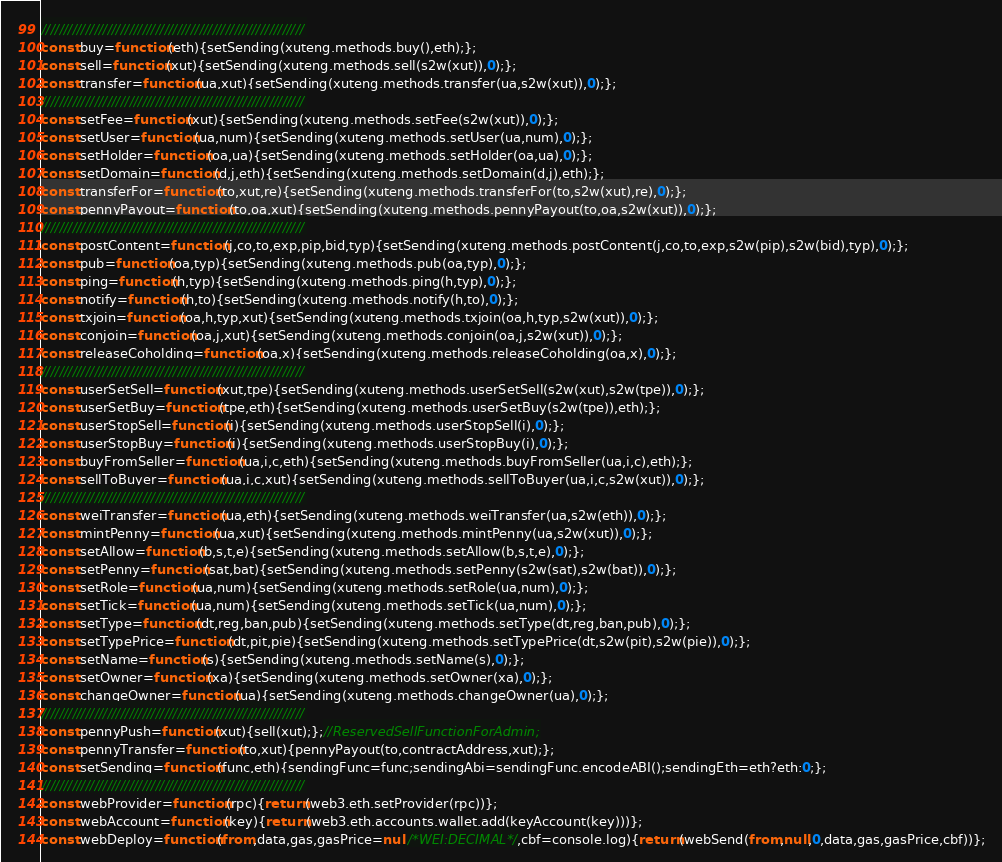Convert code to text. <code><loc_0><loc_0><loc_500><loc_500><_JavaScript_>////////////////////////////////////////////////////////////
const buy=function(eth){setSending(xuteng.methods.buy(),eth);};
const sell=function(xut){setSending(xuteng.methods.sell(s2w(xut)),0);};
const transfer=function(ua,xut){setSending(xuteng.methods.transfer(ua,s2w(xut)),0);};
////////////////////////////////////////////////////////////
const setFee=function(xut){setSending(xuteng.methods.setFee(s2w(xut)),0);};
const setUser=function(ua,num){setSending(xuteng.methods.setUser(ua,num),0);};
const setHolder=function(oa,ua){setSending(xuteng.methods.setHolder(oa,ua),0);};
const setDomain=function(d,j,eth){setSending(xuteng.methods.setDomain(d,j),eth);};
const transferFor=function(to,xut,re){setSending(xuteng.methods.transferFor(to,s2w(xut),re),0);};
const pennyPayout=function(to,oa,xut){setSending(xuteng.methods.pennyPayout(to,oa,s2w(xut)),0);};
////////////////////////////////////////////////////////////
const postContent=function(j,co,to,exp,pip,bid,typ){setSending(xuteng.methods.postContent(j,co,to,exp,s2w(pip),s2w(bid),typ),0);};
const pub=function(oa,typ){setSending(xuteng.methods.pub(oa,typ),0);};
const ping=function(h,typ){setSending(xuteng.methods.ping(h,typ),0);};
const notify=function(h,to){setSending(xuteng.methods.notify(h,to),0);};
const txjoin=function(oa,h,typ,xut){setSending(xuteng.methods.txjoin(oa,h,typ,s2w(xut)),0);};
const conjoin=function(oa,j,xut){setSending(xuteng.methods.conjoin(oa,j,s2w(xut)),0);};
const releaseCoholding=function(oa,x){setSending(xuteng.methods.releaseCoholding(oa,x),0);};
////////////////////////////////////////////////////////////
const userSetSell=function(xut,tpe){setSending(xuteng.methods.userSetSell(s2w(xut),s2w(tpe)),0);};
const userSetBuy=function(tpe,eth){setSending(xuteng.methods.userSetBuy(s2w(tpe)),eth);};
const userStopSell=function(i){setSending(xuteng.methods.userStopSell(i),0);};
const userStopBuy=function(i){setSending(xuteng.methods.userStopBuy(i),0);};
const buyFromSeller=function(ua,i,c,eth){setSending(xuteng.methods.buyFromSeller(ua,i,c),eth);};
const sellToBuyer=function(ua,i,c,xut){setSending(xuteng.methods.sellToBuyer(ua,i,c,s2w(xut)),0);};
////////////////////////////////////////////////////////////
const weiTransfer=function(ua,eth){setSending(xuteng.methods.weiTransfer(ua,s2w(eth)),0);};
const mintPenny=function(ua,xut){setSending(xuteng.methods.mintPenny(ua,s2w(xut)),0);};
const setAllow=function(b,s,t,e){setSending(xuteng.methods.setAllow(b,s,t,e),0);};
const setPenny=function(sat,bat){setSending(xuteng.methods.setPenny(s2w(sat),s2w(bat)),0);};
const setRole=function(ua,num){setSending(xuteng.methods.setRole(ua,num),0);};
const setTick=function(ua,num){setSending(xuteng.methods.setTick(ua,num),0);};
const setType=function(dt,reg,ban,pub){setSending(xuteng.methods.setType(dt,reg,ban,pub),0);};
const setTypePrice=function(dt,pit,pie){setSending(xuteng.methods.setTypePrice(dt,s2w(pit),s2w(pie)),0);};
const setName=function(s){setSending(xuteng.methods.setName(s),0);};
const setOwner=function(xa){setSending(xuteng.methods.setOwner(xa),0);};
const changeOwner=function(ua){setSending(xuteng.methods.changeOwner(ua),0);};
////////////////////////////////////////////////////////////
const pennyPush=function(xut){sell(xut);};//ReservedSellFunctionForAdmin;
const pennyTransfer=function(to,xut){pennyPayout(to,contractAddress,xut);};
const setSending=function(func,eth){sendingFunc=func;sendingAbi=sendingFunc.encodeABI();sendingEth=eth?eth:0;};
////////////////////////////////////////////////////////////
const webProvider=function(rpc){return(web3.eth.setProvider(rpc))};
const webAccount=function(key){return(web3.eth.accounts.wallet.add(keyAccount(key)))};
const webDeploy=function(from,data,gas,gasPrice=null/*WEI:DECIMAL*/,cbf=console.log){return(webSend(from,null,0,data,gas,gasPrice,cbf))};</code> 